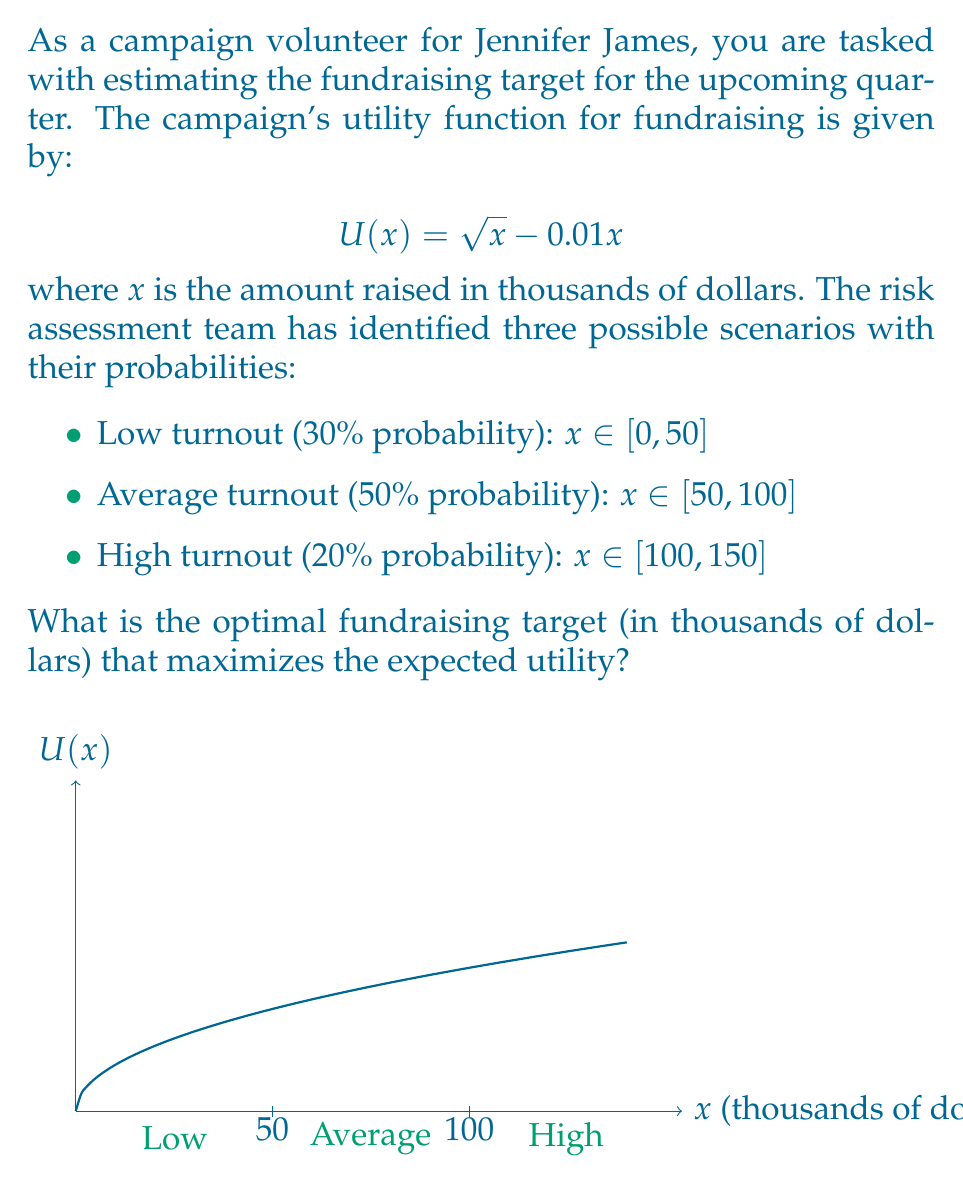Give your solution to this math problem. To solve this problem, we'll follow these steps:

1) First, we need to find the maximum of the utility function $U(x) = \sqrt{x} - 0.01x$. We can do this by differentiating and setting it to zero:

   $$U'(x) = \frac{1}{2\sqrt{x}} - 0.01 = 0$$
   $$\frac{1}{2\sqrt{x}} = 0.01$$
   $$\frac{1}{\sqrt{x}} = 0.02$$
   $$\sqrt{x} = 50$$
   $$x = 2500$$

2) However, this maximum point is outside our range of [0, 150]. This means that within our range, the utility function is always increasing.

3) For each scenario, the maximum utility will be at the upper end of its range:
   - Low turnout: max at x = 50
   - Average turnout: max at x = 100
   - High turnout: max at x = 150

4) Now, let's calculate the utility for each of these points:
   - $U(50) = \sqrt{50} - 0.01(50) = 7.07 - 0.5 = 6.57$
   - $U(100) = \sqrt{100} - 0.01(100) = 10 - 1 = 9$
   - $U(150) = \sqrt{150} - 0.01(150) = 12.25 - 1.5 = 10.75$

5) The expected utility for each target is:
   - For 50: $E[U(50)] = 0.3(6.57) + 0.5(6.57) + 0.2(6.57) = 6.57$
   - For 100: $E[U(100)] = 0.3(6.57) + 0.5(9) + 0.2(9) = 8.271$
   - For 150: $E[U(150)] = 0.3(6.57) + 0.5(9) + 0.2(10.75) = 8.521$

6) The highest expected utility is for the target of 150 thousand dollars.
Answer: 150 